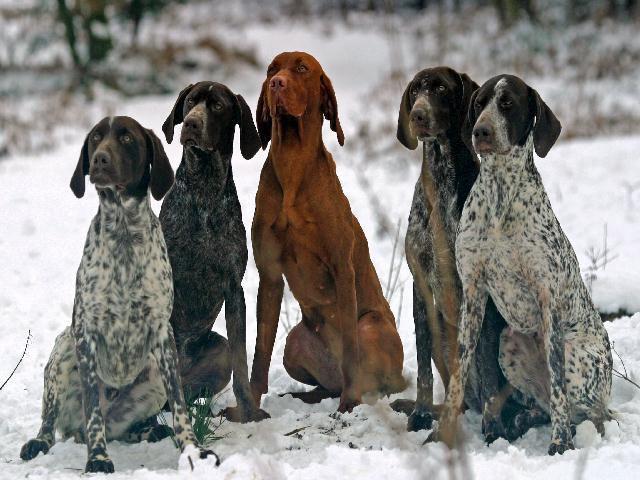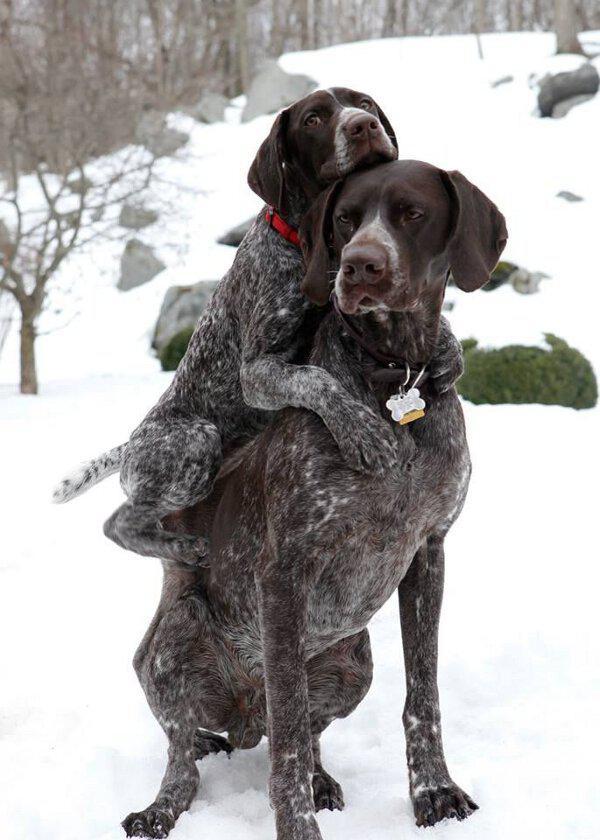The first image is the image on the left, the second image is the image on the right. Analyze the images presented: Is the assertion "At least three dogs are sitting nicely in one of the pictures." valid? Answer yes or no. Yes. The first image is the image on the left, the second image is the image on the right. For the images displayed, is the sentence "There are three dogs looking attentively forward." factually correct? Answer yes or no. No. 